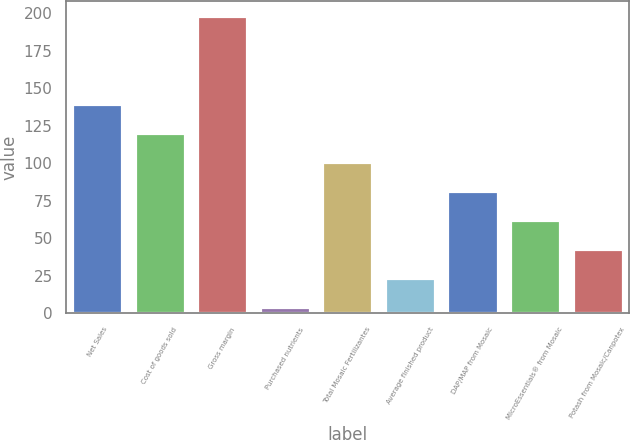<chart> <loc_0><loc_0><loc_500><loc_500><bar_chart><fcel>Net Sales<fcel>Cost of goods sold<fcel>Gross margin<fcel>Purchased nutrients<fcel>Total Mosaic Fertilizantes<fcel>Average finished product<fcel>DAP/MAP from Mosaic<fcel>MicroEssentials® from Mosaic<fcel>Potash from Mosaic/Canpotex<nl><fcel>139.8<fcel>120.4<fcel>198<fcel>4<fcel>101<fcel>23.4<fcel>81.6<fcel>62.2<fcel>42.8<nl></chart> 